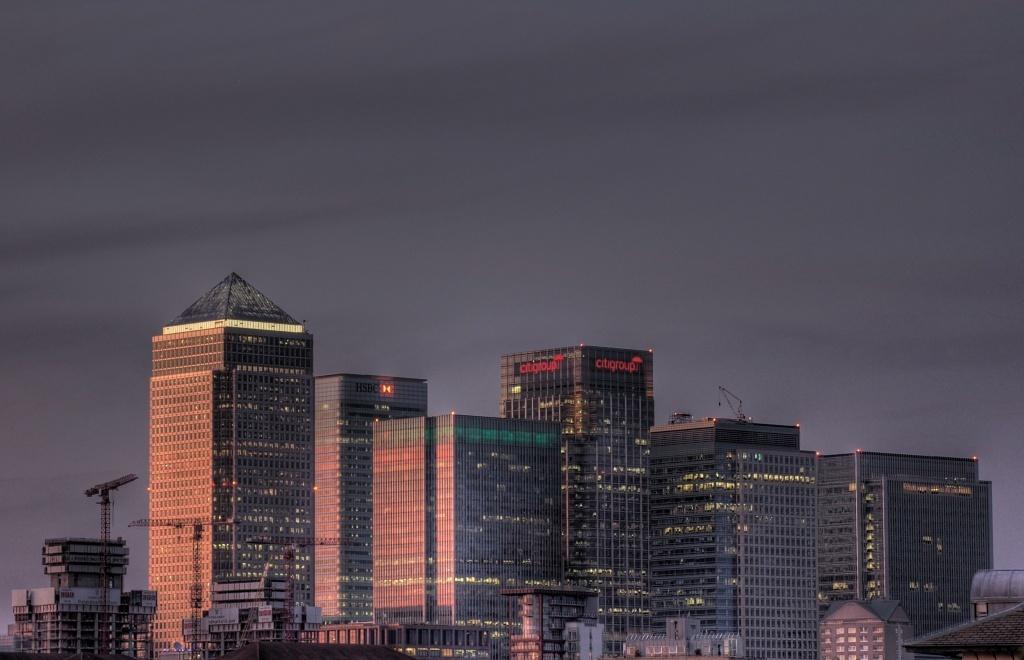Please provide a concise description of this image. This is a picture of a city, where there are buildings, and in the background there is sky. 